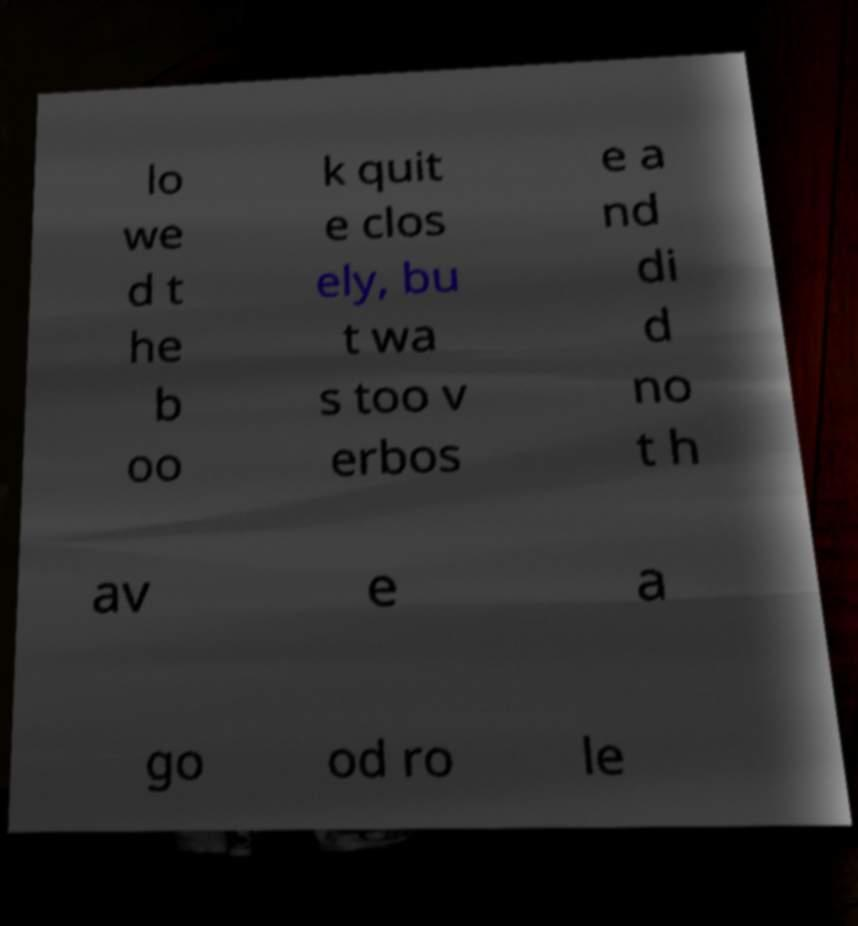I need the written content from this picture converted into text. Can you do that? lo we d t he b oo k quit e clos ely, bu t wa s too v erbos e a nd di d no t h av e a go od ro le 